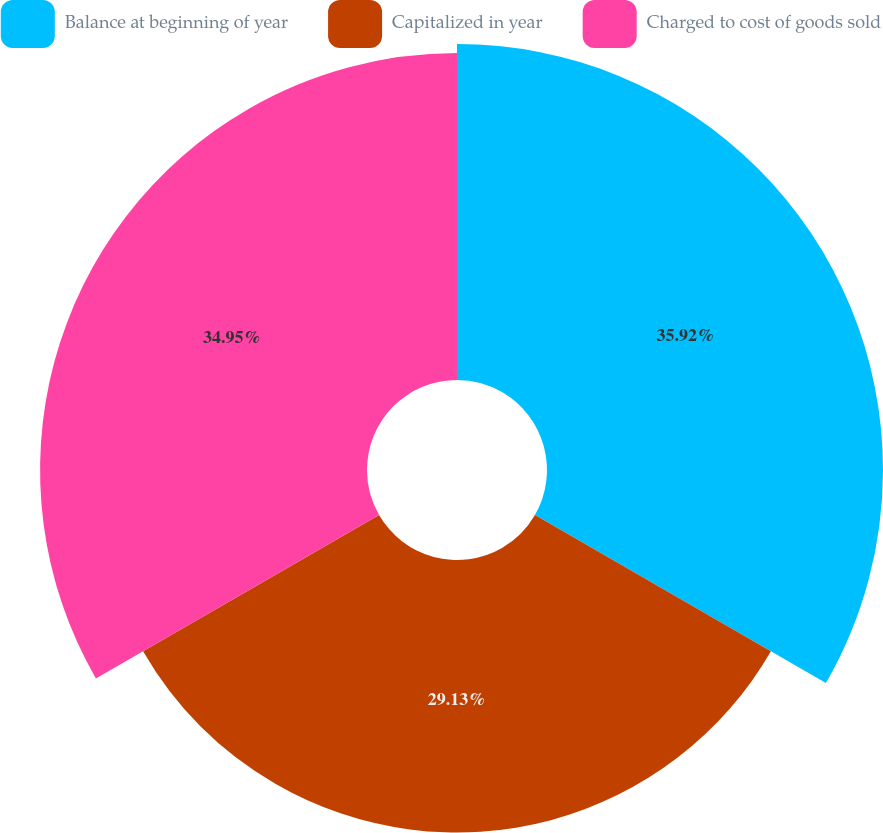Convert chart to OTSL. <chart><loc_0><loc_0><loc_500><loc_500><pie_chart><fcel>Balance at beginning of year<fcel>Capitalized in year<fcel>Charged to cost of goods sold<nl><fcel>35.92%<fcel>29.13%<fcel>34.95%<nl></chart> 